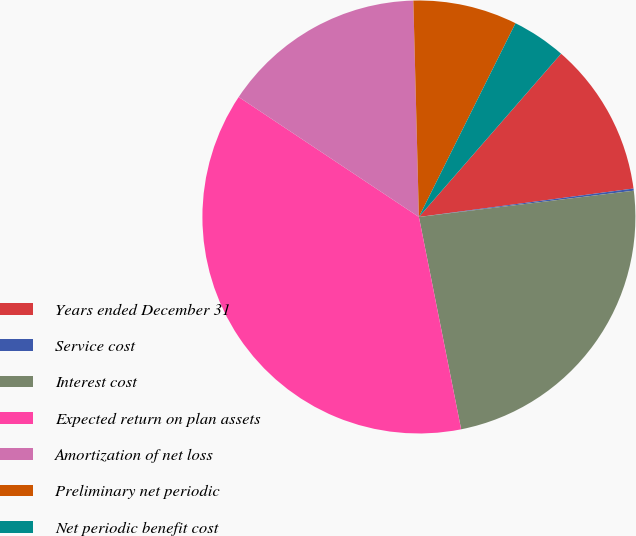<chart> <loc_0><loc_0><loc_500><loc_500><pie_chart><fcel>Years ended December 31<fcel>Service cost<fcel>Interest cost<fcel>Expected return on plan assets<fcel>Amortization of net loss<fcel>Preliminary net periodic<fcel>Net periodic benefit cost<nl><fcel>11.5%<fcel>0.16%<fcel>23.81%<fcel>37.47%<fcel>15.24%<fcel>7.77%<fcel>4.04%<nl></chart> 